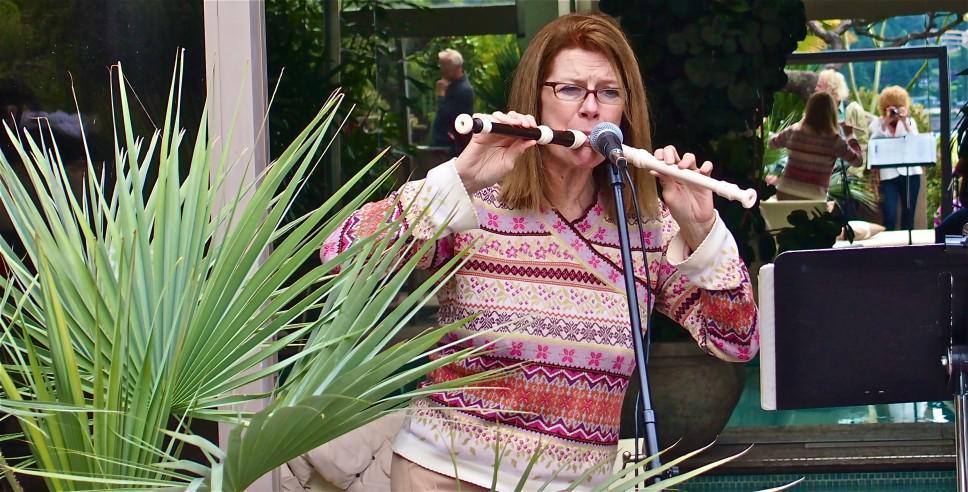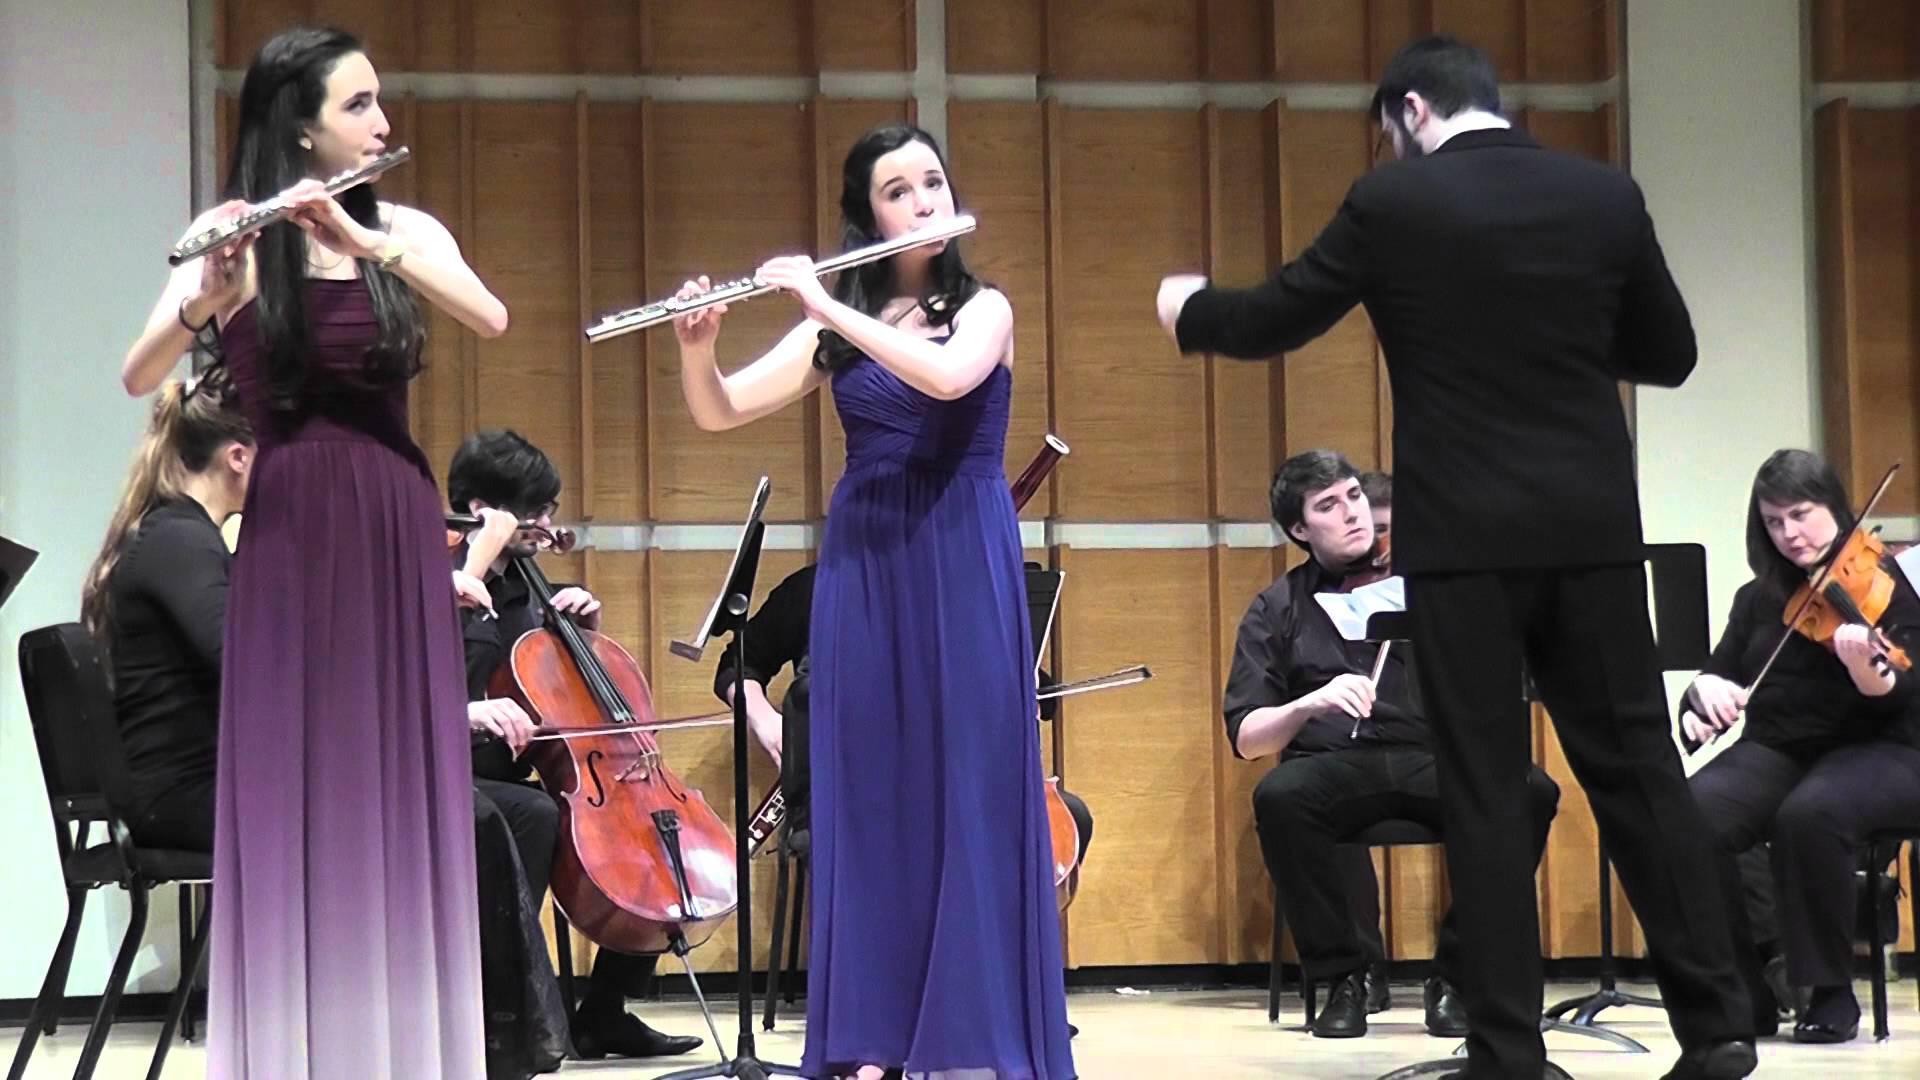The first image is the image on the left, the second image is the image on the right. Given the left and right images, does the statement "One person is playing two instruments at once in the image on the left." hold true? Answer yes or no. Yes. 